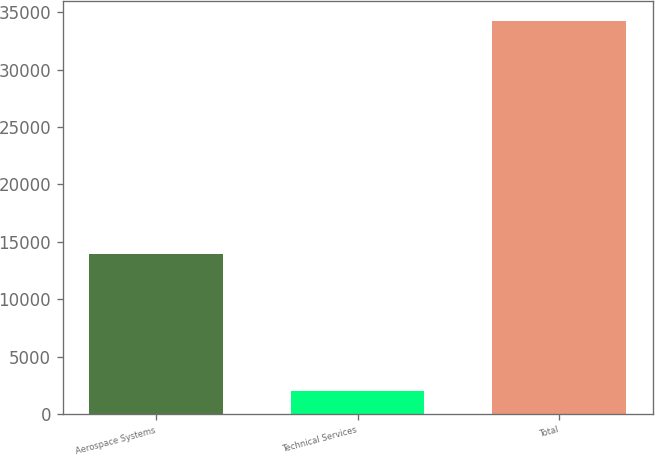Convert chart. <chart><loc_0><loc_0><loc_500><loc_500><bar_chart><fcel>Aerospace Systems<fcel>Technical Services<fcel>Total<nl><fcel>13894<fcel>1987<fcel>34264<nl></chart> 